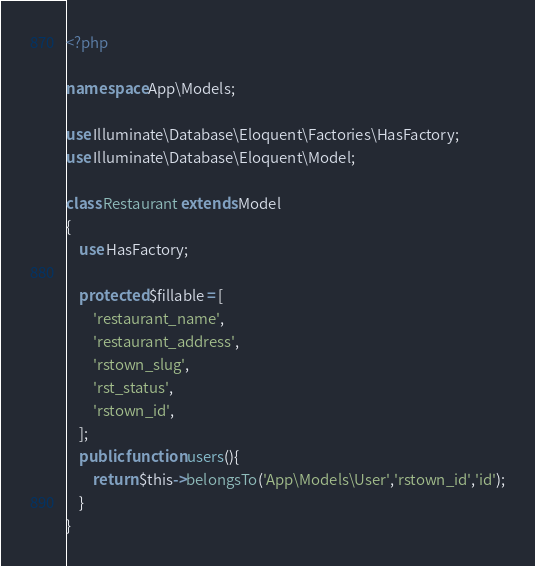<code> <loc_0><loc_0><loc_500><loc_500><_PHP_><?php

namespace App\Models;

use Illuminate\Database\Eloquent\Factories\HasFactory;
use Illuminate\Database\Eloquent\Model;

class Restaurant extends Model
{
    use HasFactory;

    protected $fillable = [
        'restaurant_name',
        'restaurant_address',
        'rstown_slug',
        'rst_status',
        'rstown_id',
    ];
    public function users(){
        return $this->belongsTo('App\Models\User','rstown_id','id');
    }
}
</code> 